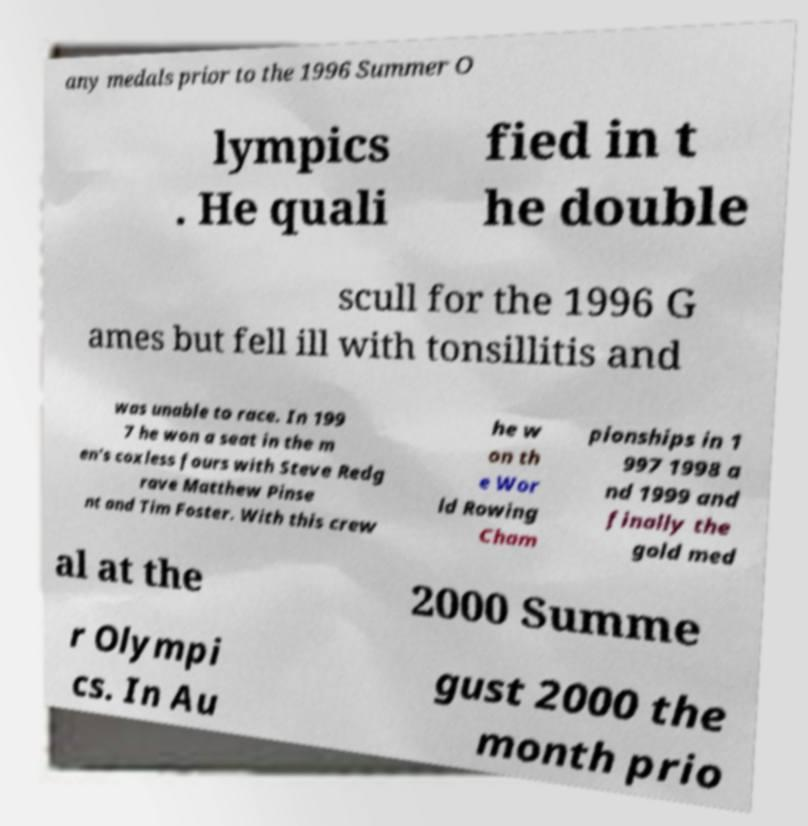Can you accurately transcribe the text from the provided image for me? any medals prior to the 1996 Summer O lympics . He quali fied in t he double scull for the 1996 G ames but fell ill with tonsillitis and was unable to race. In 199 7 he won a seat in the m en's coxless fours with Steve Redg rave Matthew Pinse nt and Tim Foster. With this crew he w on th e Wor ld Rowing Cham pionships in 1 997 1998 a nd 1999 and finally the gold med al at the 2000 Summe r Olympi cs. In Au gust 2000 the month prio 